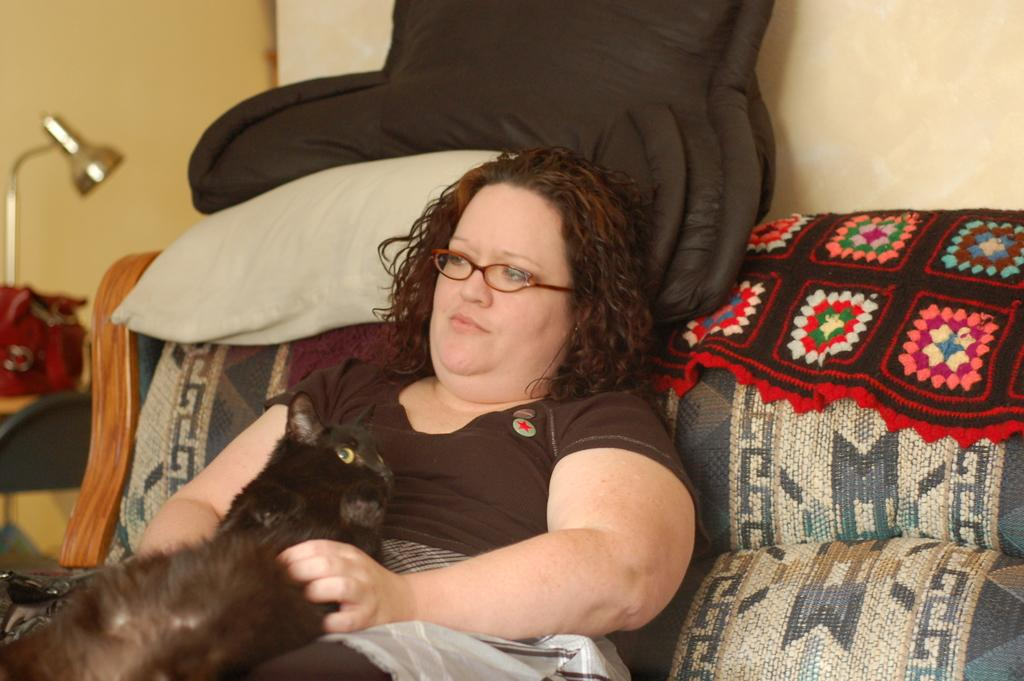Who is present in the image? There is a person in the image. What is the person wearing? The person is wearing a brown dress. What is the person doing in the image? The person is sitting on a couch. Is there any animal present in the image? Yes, there is a cat on the person. What can be seen in the background of the image? There is a black color blanket in the background of the image. What type of train is visible in the image? There is no train present in the image. What game is the person playing in the image? The image does not show the person playing any game. 